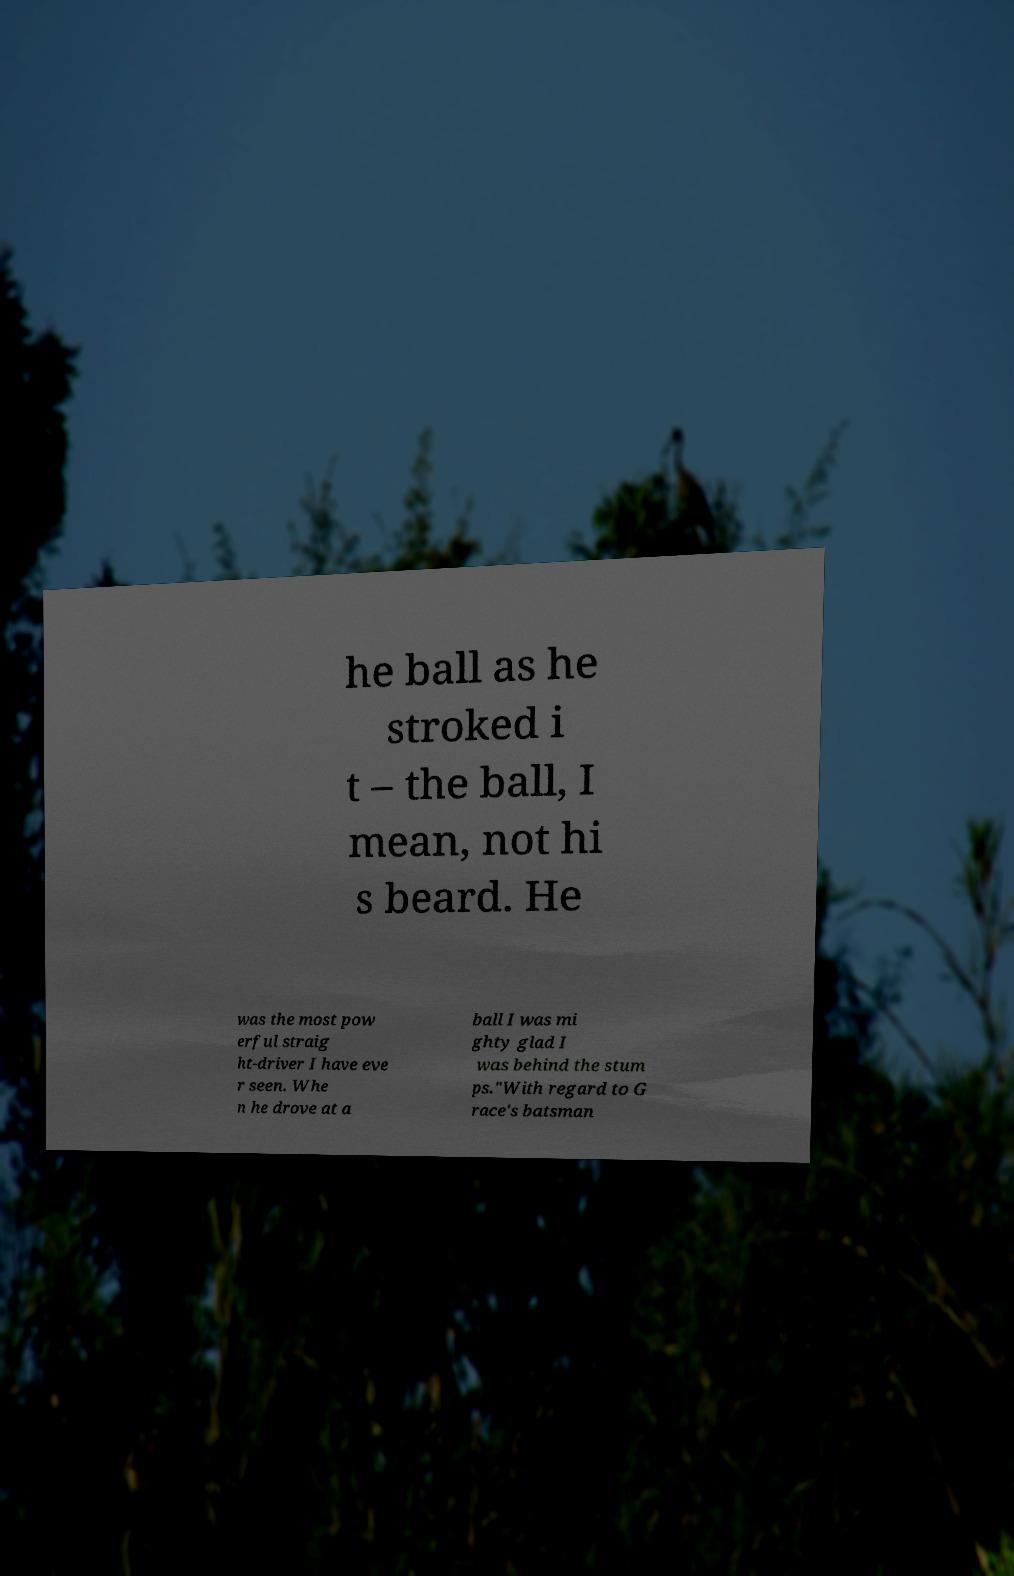I need the written content from this picture converted into text. Can you do that? he ball as he stroked i t – the ball, I mean, not hi s beard. He was the most pow erful straig ht-driver I have eve r seen. Whe n he drove at a ball I was mi ghty glad I was behind the stum ps."With regard to G race's batsman 